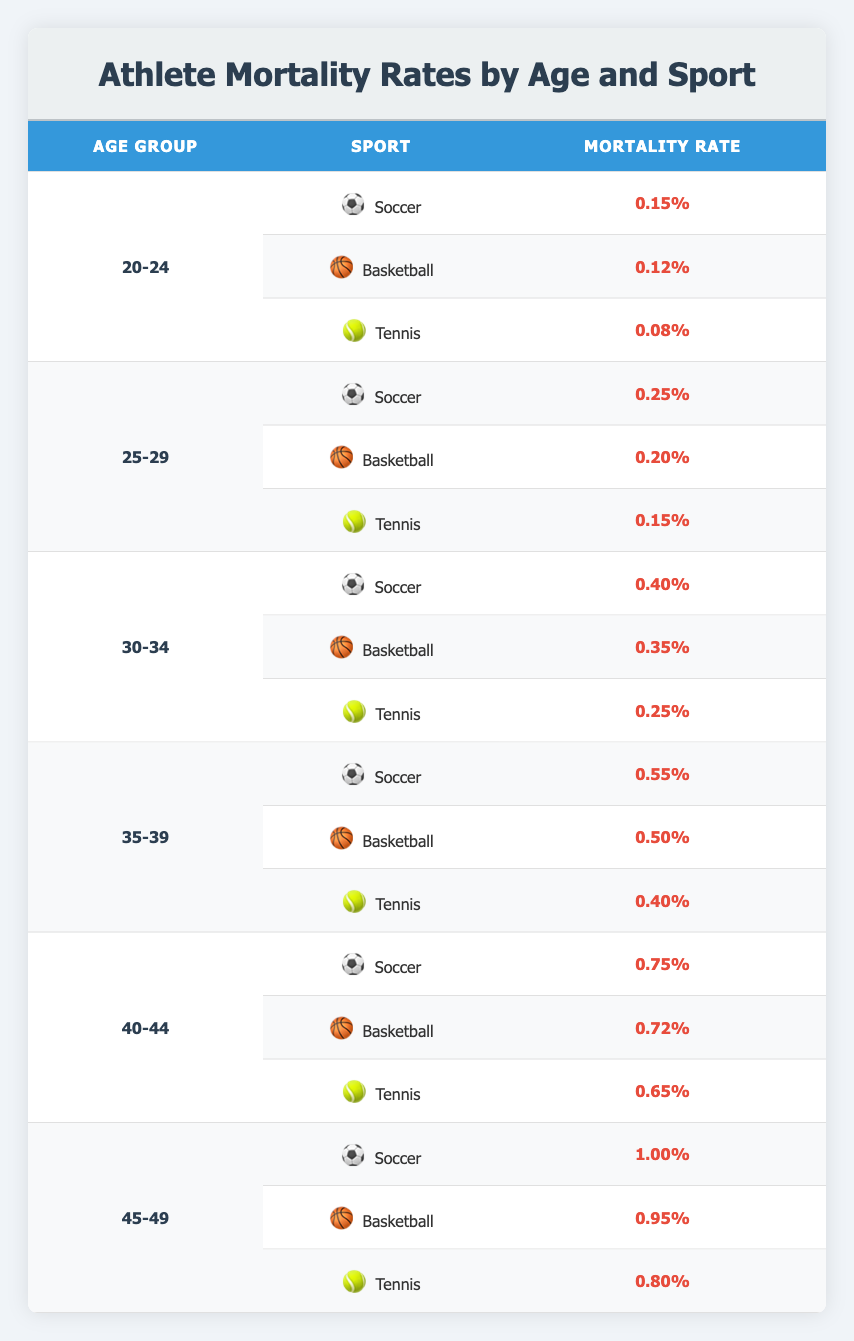What is the mortality rate for athletes aged 20-24 who play Tennis? The table shows the "Age" group as 20-24 and the corresponding "Sport" is Tennis, which has a Mortality Rate of 0.0008. This is a straightforward retrieval from the table.
Answer: 0.0008 Which sport has the highest mortality rate for athletes aged 30-34? The table lists the mortality rates for Soccer (0.0040), Basketball (0.0035), and Tennis (0.0025) for the age group 30-34. Comparing these, Soccer has the highest rate.
Answer: Soccer What is the combined mortality rate for athletes aged 45-49 across all sports? To find the combined rate, we sum the mortality rates for Soccer (0.0100), Basketball (0.0095), and Tennis (0.0080). Adding these gives: 0.0100 + 0.0095 + 0.0080 = 0.0275.
Answer: 0.0275 Is the mortality rate for Basketball higher in the 35-39 age group than in the 25-29 age group? The mortality rate for Basketball is 0.0050 in the 35-39 age group and 0.0020 in the 25-29 age group. Since 0.0050 is greater than 0.0020, the statement is true.
Answer: Yes What is the average mortality rate for Soccer players across all age groups presented in the table? The mortality rates for Soccer in various age groups are: 0.0015 (20-24), 0.0025 (25-29), 0.0040 (30-34), 0.0055 (35-39), 0.0075 (40-44), and 0.0100 (45-49). Adding these rates gives: 0.0015 + 0.0025 + 0.0040 + 0.0055 + 0.0075 + 0.0100 = 0.0310. There are 6 rates, so the average is 0.0310 / 6 ≈ 0.00517.
Answer: 0.00517 Which age group shows the lowest mortality rate for Tennis players? The mortality rates for Tennis players are 0.0008 (20-24), 0.0015 (25-29), 0.0025 (30-34), 0.0040 (35-39), 0.0065 (40-44), and 0.0080 (45-49). Comparing these rates, the lowest is 0.0008 in the 20-24 age group.
Answer: 20-24 Is it true that athletes aged 40-44 have a higher mortality rate in Tennis than those aged 30-34? The mortality rate for Tennis players aged 40-44 is 0.0065, while for those aged 30-34 it is 0.0025. Since 0.0065 is greater than 0.0025, the statement is true.
Answer: Yes What is the mortality rate difference between Soccer players aged 25-29 and 45-49? The mortality rate for Soccer players aged 25-29 is 0.0025, and for 45-49, it is 0.0100. The difference is: 0.0100 - 0.0025 = 0.0075.
Answer: 0.0075 